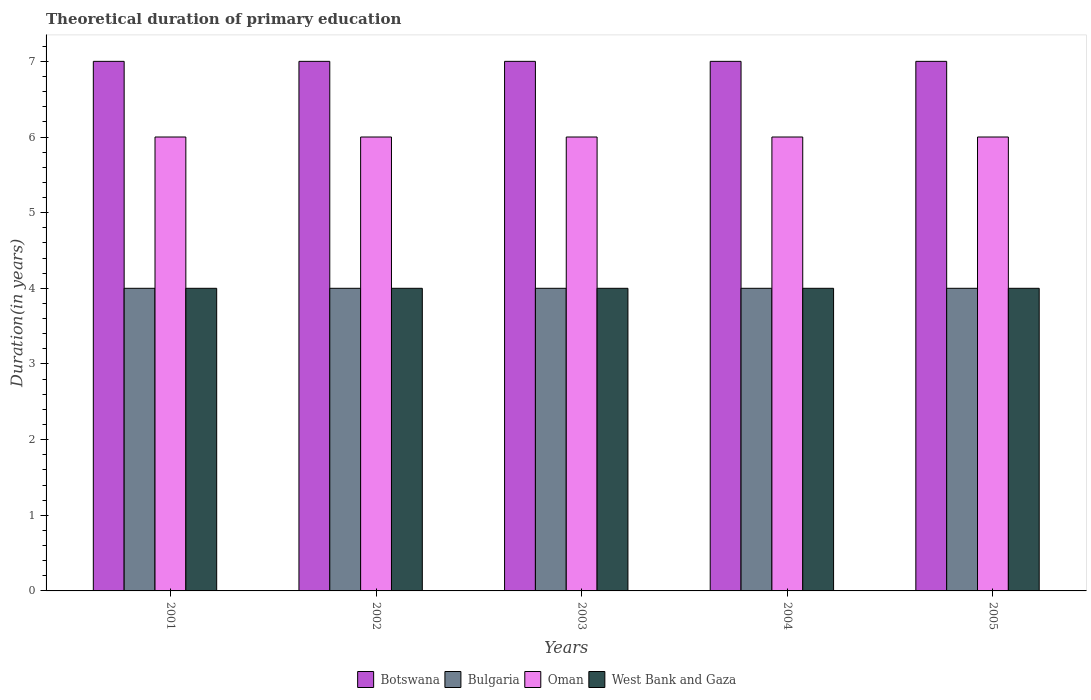How many different coloured bars are there?
Give a very brief answer. 4. How many groups of bars are there?
Provide a succinct answer. 5. Are the number of bars on each tick of the X-axis equal?
Provide a short and direct response. Yes. How many bars are there on the 3rd tick from the right?
Keep it short and to the point. 4. What is the total theoretical duration of primary education in Bulgaria in 2005?
Your answer should be very brief. 4. Across all years, what is the maximum total theoretical duration of primary education in West Bank and Gaza?
Make the answer very short. 4. Across all years, what is the minimum total theoretical duration of primary education in West Bank and Gaza?
Make the answer very short. 4. In which year was the total theoretical duration of primary education in Oman minimum?
Your answer should be very brief. 2001. What is the total total theoretical duration of primary education in Botswana in the graph?
Keep it short and to the point. 35. What is the difference between the total theoretical duration of primary education in West Bank and Gaza in 2002 and the total theoretical duration of primary education in Oman in 2004?
Provide a succinct answer. -2. In the year 2004, what is the difference between the total theoretical duration of primary education in Botswana and total theoretical duration of primary education in Bulgaria?
Your answer should be very brief. 3. In how many years, is the total theoretical duration of primary education in Oman greater than 0.8 years?
Your response must be concise. 5. What is the ratio of the total theoretical duration of primary education in Bulgaria in 2001 to that in 2002?
Keep it short and to the point. 1. Is the total theoretical duration of primary education in Oman in 2001 less than that in 2003?
Ensure brevity in your answer.  No. Is the difference between the total theoretical duration of primary education in Botswana in 2004 and 2005 greater than the difference between the total theoretical duration of primary education in Bulgaria in 2004 and 2005?
Your answer should be very brief. No. What is the difference between the highest and the lowest total theoretical duration of primary education in Oman?
Give a very brief answer. 0. In how many years, is the total theoretical duration of primary education in Bulgaria greater than the average total theoretical duration of primary education in Bulgaria taken over all years?
Ensure brevity in your answer.  0. What does the 1st bar from the left in 2001 represents?
Offer a terse response. Botswana. What does the 2nd bar from the right in 2001 represents?
Offer a very short reply. Oman. Is it the case that in every year, the sum of the total theoretical duration of primary education in Botswana and total theoretical duration of primary education in Bulgaria is greater than the total theoretical duration of primary education in West Bank and Gaza?
Ensure brevity in your answer.  Yes. How many bars are there?
Provide a succinct answer. 20. Does the graph contain any zero values?
Make the answer very short. No. Where does the legend appear in the graph?
Give a very brief answer. Bottom center. How many legend labels are there?
Ensure brevity in your answer.  4. What is the title of the graph?
Offer a very short reply. Theoretical duration of primary education. Does "Kenya" appear as one of the legend labels in the graph?
Give a very brief answer. No. What is the label or title of the X-axis?
Provide a succinct answer. Years. What is the label or title of the Y-axis?
Keep it short and to the point. Duration(in years). What is the Duration(in years) in Bulgaria in 2001?
Your answer should be compact. 4. What is the Duration(in years) in Oman in 2001?
Make the answer very short. 6. What is the Duration(in years) in West Bank and Gaza in 2001?
Ensure brevity in your answer.  4. What is the Duration(in years) of Botswana in 2002?
Keep it short and to the point. 7. What is the Duration(in years) of Bulgaria in 2002?
Offer a very short reply. 4. What is the Duration(in years) in Botswana in 2003?
Keep it short and to the point. 7. What is the Duration(in years) of Oman in 2003?
Keep it short and to the point. 6. What is the Duration(in years) in West Bank and Gaza in 2003?
Give a very brief answer. 4. What is the Duration(in years) of Botswana in 2004?
Give a very brief answer. 7. What is the Duration(in years) in Bulgaria in 2004?
Make the answer very short. 4. What is the Duration(in years) of Oman in 2004?
Ensure brevity in your answer.  6. What is the Duration(in years) of West Bank and Gaza in 2004?
Keep it short and to the point. 4. What is the Duration(in years) of Bulgaria in 2005?
Provide a short and direct response. 4. What is the Duration(in years) in Oman in 2005?
Your answer should be compact. 6. What is the Duration(in years) of West Bank and Gaza in 2005?
Give a very brief answer. 4. Across all years, what is the maximum Duration(in years) of Botswana?
Give a very brief answer. 7. Across all years, what is the maximum Duration(in years) of Bulgaria?
Keep it short and to the point. 4. Across all years, what is the maximum Duration(in years) in Oman?
Offer a terse response. 6. Across all years, what is the maximum Duration(in years) of West Bank and Gaza?
Your response must be concise. 4. Across all years, what is the minimum Duration(in years) in Bulgaria?
Provide a short and direct response. 4. What is the total Duration(in years) in Botswana in the graph?
Give a very brief answer. 35. What is the total Duration(in years) in Oman in the graph?
Keep it short and to the point. 30. What is the total Duration(in years) of West Bank and Gaza in the graph?
Your answer should be very brief. 20. What is the difference between the Duration(in years) in Botswana in 2001 and that in 2002?
Your answer should be compact. 0. What is the difference between the Duration(in years) in Bulgaria in 2001 and that in 2002?
Give a very brief answer. 0. What is the difference between the Duration(in years) of Oman in 2001 and that in 2002?
Ensure brevity in your answer.  0. What is the difference between the Duration(in years) in West Bank and Gaza in 2001 and that in 2002?
Keep it short and to the point. 0. What is the difference between the Duration(in years) in Botswana in 2001 and that in 2003?
Provide a succinct answer. 0. What is the difference between the Duration(in years) of Bulgaria in 2001 and that in 2003?
Give a very brief answer. 0. What is the difference between the Duration(in years) in West Bank and Gaza in 2001 and that in 2003?
Provide a succinct answer. 0. What is the difference between the Duration(in years) in Bulgaria in 2001 and that in 2004?
Provide a succinct answer. 0. What is the difference between the Duration(in years) in Oman in 2001 and that in 2004?
Keep it short and to the point. 0. What is the difference between the Duration(in years) in West Bank and Gaza in 2001 and that in 2004?
Your answer should be very brief. 0. What is the difference between the Duration(in years) in Botswana in 2001 and that in 2005?
Give a very brief answer. 0. What is the difference between the Duration(in years) of Oman in 2001 and that in 2005?
Offer a terse response. 0. What is the difference between the Duration(in years) in West Bank and Gaza in 2001 and that in 2005?
Keep it short and to the point. 0. What is the difference between the Duration(in years) in Botswana in 2002 and that in 2003?
Make the answer very short. 0. What is the difference between the Duration(in years) in Oman in 2002 and that in 2003?
Ensure brevity in your answer.  0. What is the difference between the Duration(in years) of West Bank and Gaza in 2002 and that in 2004?
Make the answer very short. 0. What is the difference between the Duration(in years) in Botswana in 2003 and that in 2004?
Your answer should be very brief. 0. What is the difference between the Duration(in years) in Bulgaria in 2003 and that in 2004?
Your response must be concise. 0. What is the difference between the Duration(in years) in West Bank and Gaza in 2003 and that in 2004?
Your answer should be compact. 0. What is the difference between the Duration(in years) of Botswana in 2003 and that in 2005?
Your answer should be very brief. 0. What is the difference between the Duration(in years) of Bulgaria in 2003 and that in 2005?
Your answer should be compact. 0. What is the difference between the Duration(in years) of Oman in 2003 and that in 2005?
Your answer should be compact. 0. What is the difference between the Duration(in years) in West Bank and Gaza in 2003 and that in 2005?
Offer a terse response. 0. What is the difference between the Duration(in years) in West Bank and Gaza in 2004 and that in 2005?
Give a very brief answer. 0. What is the difference between the Duration(in years) in Botswana in 2001 and the Duration(in years) in Bulgaria in 2002?
Your answer should be compact. 3. What is the difference between the Duration(in years) in Bulgaria in 2001 and the Duration(in years) in Oman in 2002?
Your response must be concise. -2. What is the difference between the Duration(in years) in Oman in 2001 and the Duration(in years) in West Bank and Gaza in 2002?
Your response must be concise. 2. What is the difference between the Duration(in years) in Botswana in 2001 and the Duration(in years) in Bulgaria in 2003?
Keep it short and to the point. 3. What is the difference between the Duration(in years) of Botswana in 2001 and the Duration(in years) of Oman in 2003?
Provide a succinct answer. 1. What is the difference between the Duration(in years) of Bulgaria in 2001 and the Duration(in years) of Oman in 2003?
Keep it short and to the point. -2. What is the difference between the Duration(in years) in Bulgaria in 2001 and the Duration(in years) in West Bank and Gaza in 2003?
Your answer should be very brief. 0. What is the difference between the Duration(in years) in Bulgaria in 2001 and the Duration(in years) in West Bank and Gaza in 2004?
Your response must be concise. 0. What is the difference between the Duration(in years) of Oman in 2001 and the Duration(in years) of West Bank and Gaza in 2004?
Offer a terse response. 2. What is the difference between the Duration(in years) of Oman in 2001 and the Duration(in years) of West Bank and Gaza in 2005?
Keep it short and to the point. 2. What is the difference between the Duration(in years) in Botswana in 2002 and the Duration(in years) in West Bank and Gaza in 2003?
Provide a succinct answer. 3. What is the difference between the Duration(in years) in Bulgaria in 2002 and the Duration(in years) in West Bank and Gaza in 2003?
Your response must be concise. 0. What is the difference between the Duration(in years) of Botswana in 2002 and the Duration(in years) of Bulgaria in 2004?
Keep it short and to the point. 3. What is the difference between the Duration(in years) of Botswana in 2002 and the Duration(in years) of Oman in 2004?
Your response must be concise. 1. What is the difference between the Duration(in years) in Botswana in 2002 and the Duration(in years) in West Bank and Gaza in 2004?
Offer a very short reply. 3. What is the difference between the Duration(in years) in Bulgaria in 2002 and the Duration(in years) in Oman in 2004?
Provide a succinct answer. -2. What is the difference between the Duration(in years) in Oman in 2002 and the Duration(in years) in West Bank and Gaza in 2004?
Provide a succinct answer. 2. What is the difference between the Duration(in years) in Botswana in 2002 and the Duration(in years) in Bulgaria in 2005?
Your response must be concise. 3. What is the difference between the Duration(in years) in Botswana in 2002 and the Duration(in years) in West Bank and Gaza in 2005?
Keep it short and to the point. 3. What is the difference between the Duration(in years) of Bulgaria in 2002 and the Duration(in years) of Oman in 2005?
Your response must be concise. -2. What is the difference between the Duration(in years) in Oman in 2002 and the Duration(in years) in West Bank and Gaza in 2005?
Offer a very short reply. 2. What is the difference between the Duration(in years) of Botswana in 2003 and the Duration(in years) of Bulgaria in 2004?
Provide a short and direct response. 3. What is the difference between the Duration(in years) in Botswana in 2003 and the Duration(in years) in Oman in 2004?
Give a very brief answer. 1. What is the difference between the Duration(in years) of Bulgaria in 2003 and the Duration(in years) of Oman in 2004?
Your answer should be compact. -2. What is the difference between the Duration(in years) in Oman in 2003 and the Duration(in years) in West Bank and Gaza in 2004?
Give a very brief answer. 2. What is the difference between the Duration(in years) of Botswana in 2003 and the Duration(in years) of Bulgaria in 2005?
Give a very brief answer. 3. What is the difference between the Duration(in years) in Botswana in 2003 and the Duration(in years) in Oman in 2005?
Your answer should be very brief. 1. What is the difference between the Duration(in years) in Bulgaria in 2003 and the Duration(in years) in Oman in 2005?
Keep it short and to the point. -2. What is the difference between the Duration(in years) in Bulgaria in 2003 and the Duration(in years) in West Bank and Gaza in 2005?
Ensure brevity in your answer.  0. What is the difference between the Duration(in years) of Oman in 2003 and the Duration(in years) of West Bank and Gaza in 2005?
Provide a succinct answer. 2. What is the difference between the Duration(in years) in Botswana in 2004 and the Duration(in years) in Oman in 2005?
Keep it short and to the point. 1. What is the difference between the Duration(in years) in Botswana in 2004 and the Duration(in years) in West Bank and Gaza in 2005?
Make the answer very short. 3. What is the difference between the Duration(in years) of Bulgaria in 2004 and the Duration(in years) of West Bank and Gaza in 2005?
Your response must be concise. 0. What is the difference between the Duration(in years) of Oman in 2004 and the Duration(in years) of West Bank and Gaza in 2005?
Give a very brief answer. 2. What is the average Duration(in years) of Botswana per year?
Offer a very short reply. 7. What is the average Duration(in years) in West Bank and Gaza per year?
Give a very brief answer. 4. In the year 2001, what is the difference between the Duration(in years) in Bulgaria and Duration(in years) in Oman?
Make the answer very short. -2. In the year 2002, what is the difference between the Duration(in years) in Botswana and Duration(in years) in West Bank and Gaza?
Your answer should be very brief. 3. In the year 2002, what is the difference between the Duration(in years) in Bulgaria and Duration(in years) in West Bank and Gaza?
Provide a short and direct response. 0. In the year 2002, what is the difference between the Duration(in years) in Oman and Duration(in years) in West Bank and Gaza?
Your answer should be compact. 2. In the year 2003, what is the difference between the Duration(in years) of Botswana and Duration(in years) of Oman?
Your response must be concise. 1. In the year 2003, what is the difference between the Duration(in years) in Botswana and Duration(in years) in West Bank and Gaza?
Give a very brief answer. 3. In the year 2003, what is the difference between the Duration(in years) in Bulgaria and Duration(in years) in Oman?
Provide a short and direct response. -2. In the year 2003, what is the difference between the Duration(in years) of Bulgaria and Duration(in years) of West Bank and Gaza?
Provide a succinct answer. 0. In the year 2003, what is the difference between the Duration(in years) of Oman and Duration(in years) of West Bank and Gaza?
Offer a very short reply. 2. In the year 2004, what is the difference between the Duration(in years) of Botswana and Duration(in years) of Oman?
Your response must be concise. 1. In the year 2004, what is the difference between the Duration(in years) in Botswana and Duration(in years) in West Bank and Gaza?
Provide a short and direct response. 3. In the year 2004, what is the difference between the Duration(in years) in Bulgaria and Duration(in years) in Oman?
Keep it short and to the point. -2. In the year 2004, what is the difference between the Duration(in years) in Bulgaria and Duration(in years) in West Bank and Gaza?
Offer a terse response. 0. In the year 2005, what is the difference between the Duration(in years) of Botswana and Duration(in years) of Bulgaria?
Provide a short and direct response. 3. In the year 2005, what is the difference between the Duration(in years) in Botswana and Duration(in years) in Oman?
Your response must be concise. 1. In the year 2005, what is the difference between the Duration(in years) in Botswana and Duration(in years) in West Bank and Gaza?
Make the answer very short. 3. In the year 2005, what is the difference between the Duration(in years) in Bulgaria and Duration(in years) in West Bank and Gaza?
Provide a succinct answer. 0. In the year 2005, what is the difference between the Duration(in years) of Oman and Duration(in years) of West Bank and Gaza?
Your answer should be very brief. 2. What is the ratio of the Duration(in years) of Botswana in 2001 to that in 2002?
Offer a very short reply. 1. What is the ratio of the Duration(in years) in West Bank and Gaza in 2001 to that in 2002?
Give a very brief answer. 1. What is the ratio of the Duration(in years) of Oman in 2001 to that in 2003?
Your response must be concise. 1. What is the ratio of the Duration(in years) of Botswana in 2001 to that in 2004?
Provide a succinct answer. 1. What is the ratio of the Duration(in years) of Bulgaria in 2001 to that in 2004?
Make the answer very short. 1. What is the ratio of the Duration(in years) in Botswana in 2001 to that in 2005?
Make the answer very short. 1. What is the ratio of the Duration(in years) of Oman in 2001 to that in 2005?
Ensure brevity in your answer.  1. What is the ratio of the Duration(in years) in West Bank and Gaza in 2001 to that in 2005?
Your response must be concise. 1. What is the ratio of the Duration(in years) in West Bank and Gaza in 2002 to that in 2003?
Give a very brief answer. 1. What is the ratio of the Duration(in years) in Bulgaria in 2002 to that in 2004?
Your answer should be compact. 1. What is the ratio of the Duration(in years) in Oman in 2002 to that in 2004?
Offer a terse response. 1. What is the ratio of the Duration(in years) in Botswana in 2002 to that in 2005?
Offer a terse response. 1. What is the ratio of the Duration(in years) in Oman in 2002 to that in 2005?
Keep it short and to the point. 1. What is the ratio of the Duration(in years) in West Bank and Gaza in 2002 to that in 2005?
Offer a very short reply. 1. What is the ratio of the Duration(in years) in West Bank and Gaza in 2003 to that in 2004?
Keep it short and to the point. 1. What is the ratio of the Duration(in years) in Bulgaria in 2003 to that in 2005?
Offer a terse response. 1. What is the ratio of the Duration(in years) of Oman in 2003 to that in 2005?
Your answer should be very brief. 1. What is the ratio of the Duration(in years) in West Bank and Gaza in 2003 to that in 2005?
Your answer should be compact. 1. What is the ratio of the Duration(in years) of Botswana in 2004 to that in 2005?
Give a very brief answer. 1. What is the ratio of the Duration(in years) in Bulgaria in 2004 to that in 2005?
Your response must be concise. 1. What is the ratio of the Duration(in years) of Oman in 2004 to that in 2005?
Offer a terse response. 1. What is the difference between the highest and the second highest Duration(in years) in Bulgaria?
Your response must be concise. 0. What is the difference between the highest and the second highest Duration(in years) of West Bank and Gaza?
Offer a terse response. 0. What is the difference between the highest and the lowest Duration(in years) in West Bank and Gaza?
Offer a very short reply. 0. 